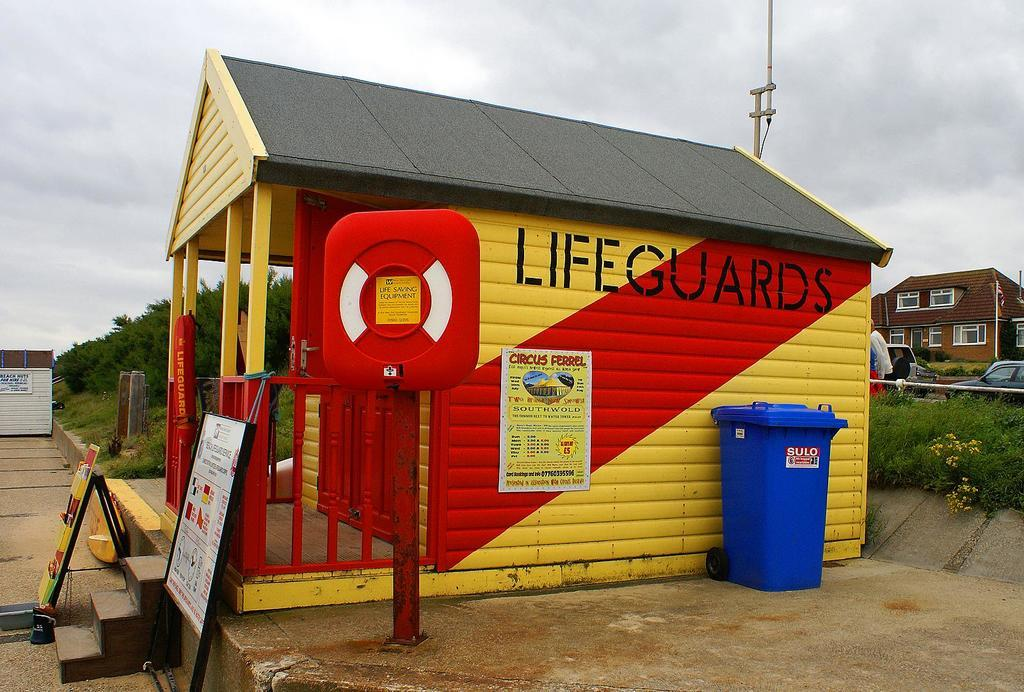<image>
Relay a brief, clear account of the picture shown. Shed that is yellow and red, which says Lifeguards on the side. 